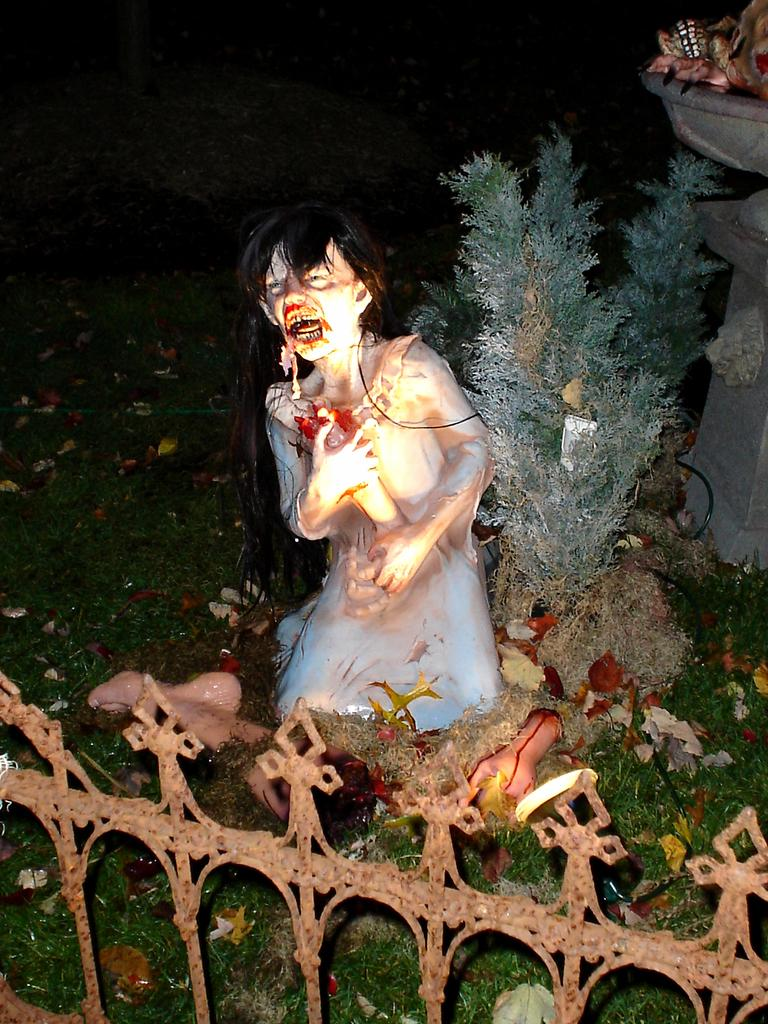What can be seen in the image that serves as a barrier or boundary? There is a railing in the image. What type of natural environment is visible behind the railing? There is a grassland behind the railing. What artistic feature is present on the grassland? There is a sculpture on the grassland. What type of plant is visible on the grassland? There is a plant on the grassland. What water feature can be seen on the grassland? There is a fountain on the grassland. What type of song is being sung by the plant on the grassland? There is no song being sung by the plant on the grassland; it is a plant and does not have the ability to sing. What type of vase is present on the grassland? There is no vase present on the grassland; the image mentions a sculpture, plant, and fountain, but not a vase. 